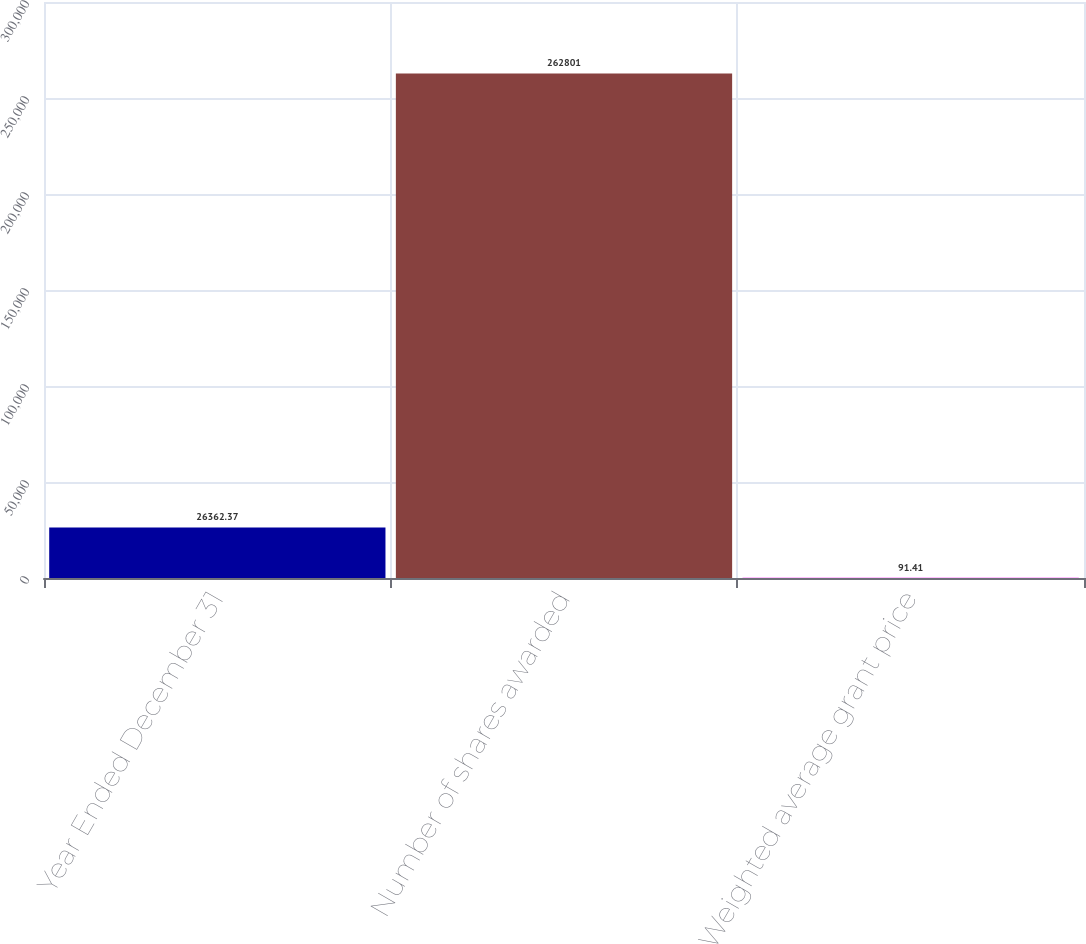Convert chart to OTSL. <chart><loc_0><loc_0><loc_500><loc_500><bar_chart><fcel>Year Ended December 31<fcel>Number of shares awarded<fcel>Weighted average grant price<nl><fcel>26362.4<fcel>262801<fcel>91.41<nl></chart> 